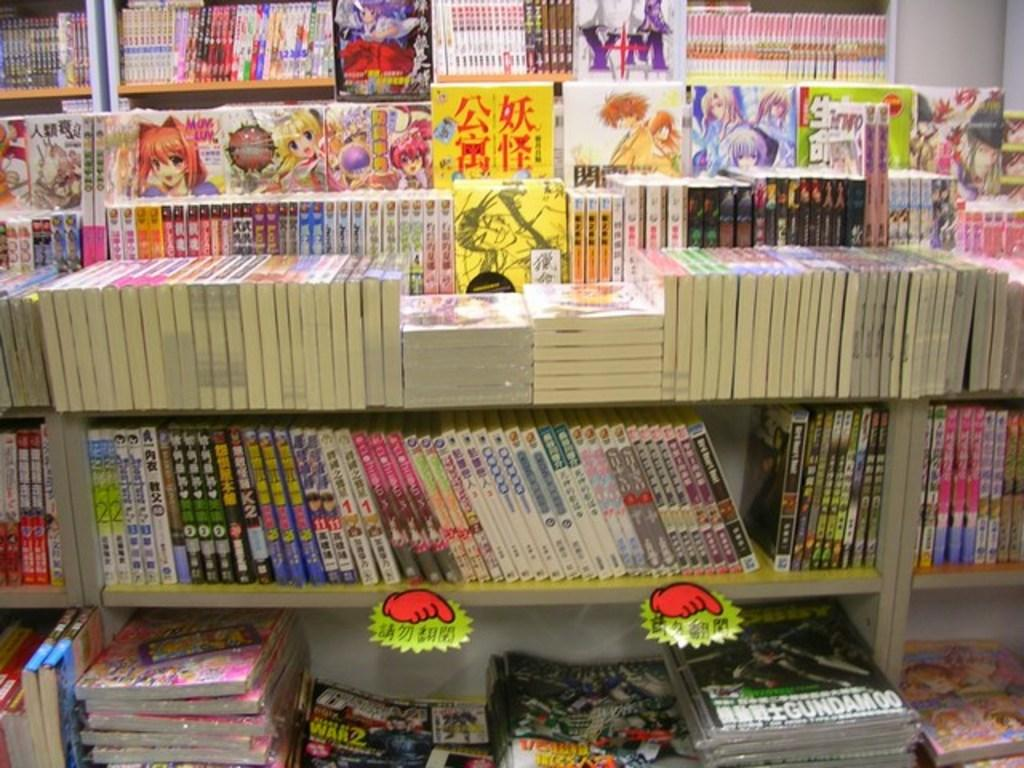<image>
Offer a succinct explanation of the picture presented. A variety of books and magazines are on display including one for Gundam 00. 